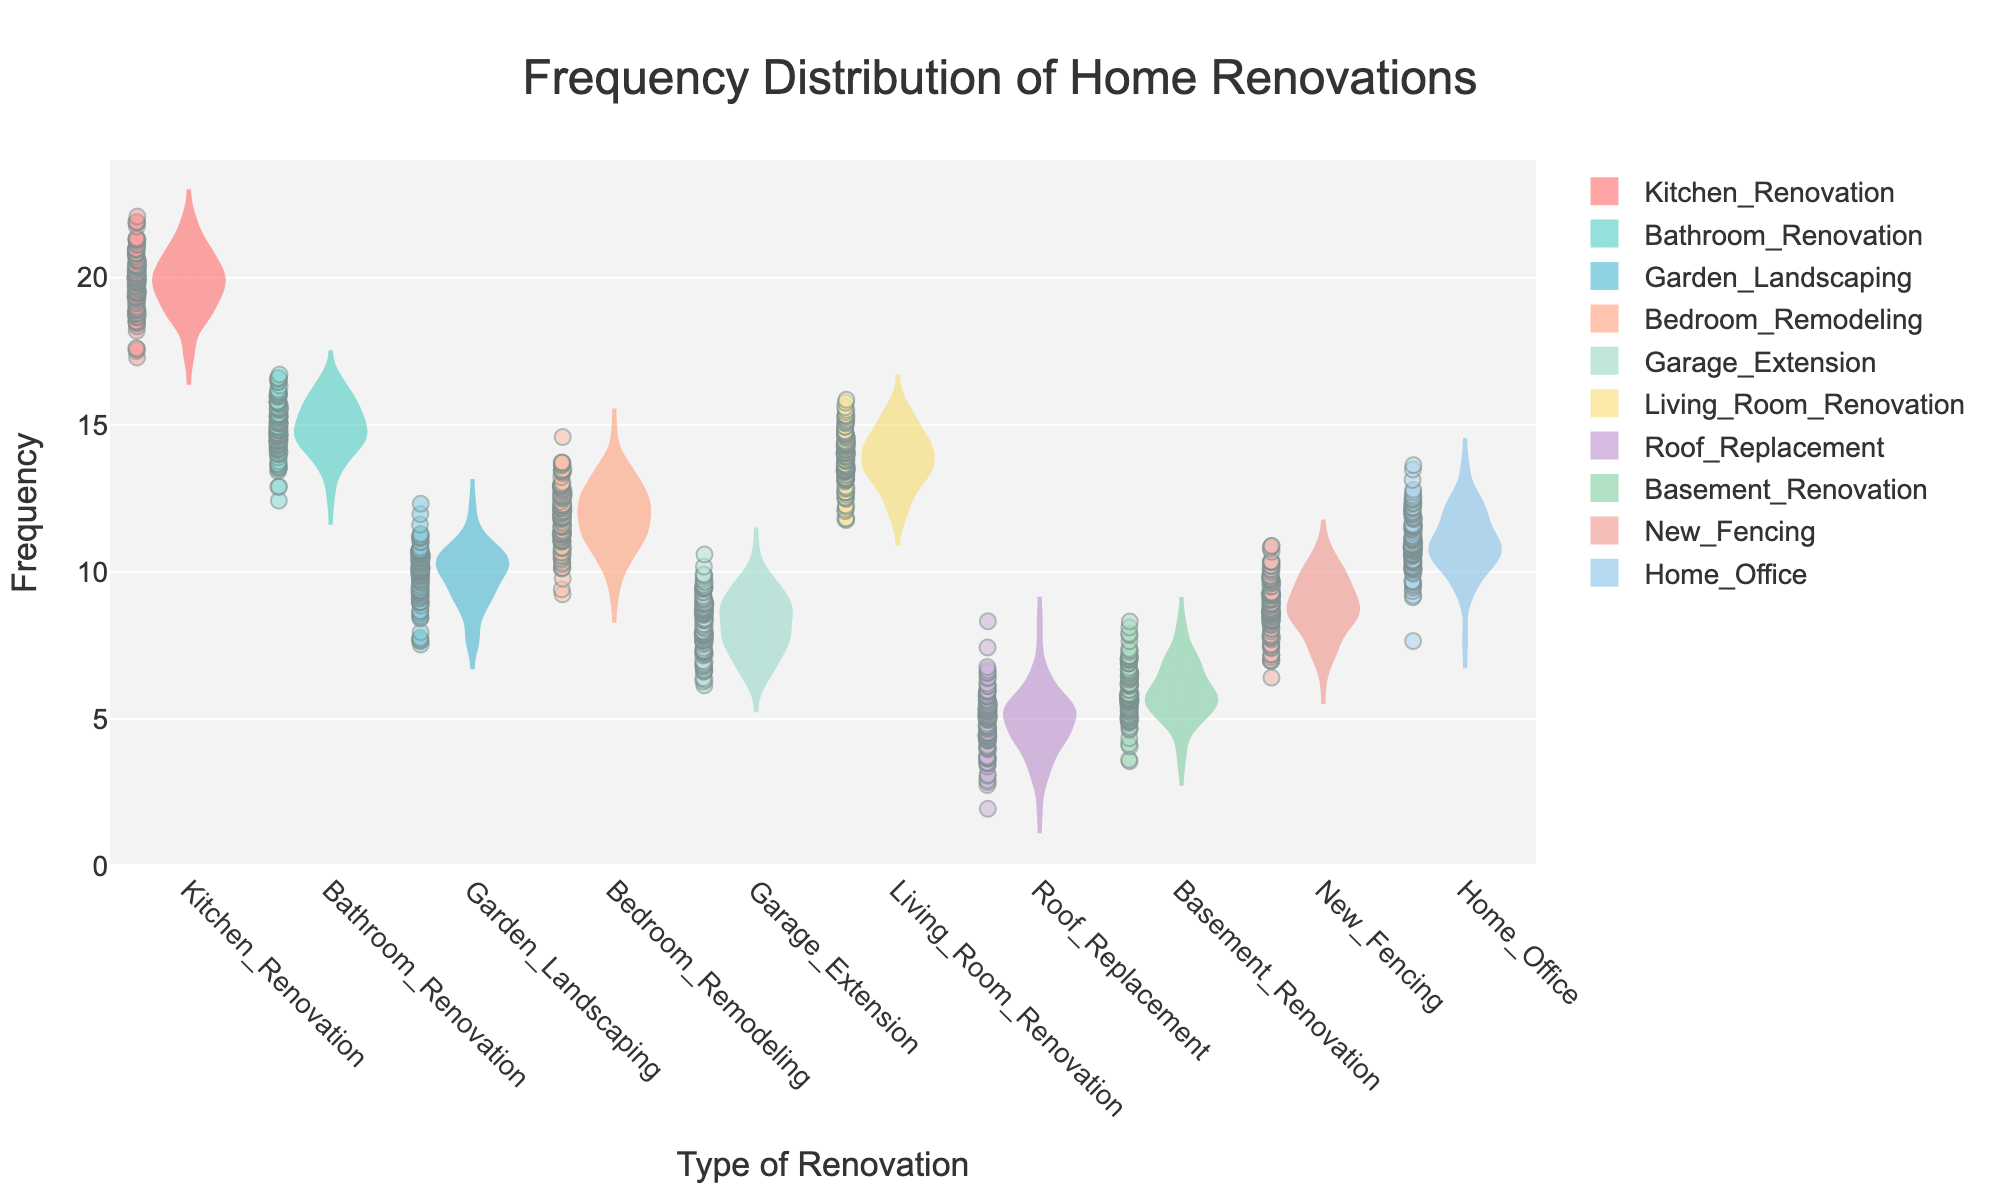What is the title of the figure? The title of the figure is usually found at the top and summarizes the main content of the chart. In this case, the title is shown at the top center of the plot.
Answer: Frequency Distribution of Home Renovations Which renovation type shows the highest frequency distribution? To determine the renovation type with the highest frequency distribution, look for the violin plot with the highest central mean line. The Kitchen Renovation has the highest mean.
Answer: Kitchen Renovation What is the range of the y-axis? The range of the y-axis can be identified by looking at the minimum and maximum values on the axis. Here, the y-axis range is from 0 to a value slightly beyond the maximum recorded frequency.
Answer: 0 to 24 How many renovation types are compared in the chart? Count the number of unique violin plots in the figure to determine the number of renovation types. Each plot represents a different type of renovation.
Answer: 10 Which renovation type has the lowest frequency distribution? Look for the violin plot with the lowest central mean line. Here, the Roof Replacement has the lowest mean frequency.
Answer: Roof Replacement What is the approximate mean frequency of Garden Landscaping renovations? The mean frequency of each violin plot can be identified by the horizontal line within the plot. For Garden Landscaping, it's around the central horizontal line.
Answer: 10 How does the frequency of Bathroom Renovation compare to Home Office renovations? Look at the central mean lines of each respective violin plot and compare. Bathroom Renovation has a mean slightly higher than Home Office.
Answer: Bathroom Renovation is higher What can you say about the variability within the Kitchen Renovation frequency? Examine the width and spread of the Kitchen Renovation's violin plot. A wider plot indicates higher variability, while a narrower plot denotes low variability. The Kitchen Renovation plot has moderate variability.
Answer: Moderate variability Which two renovation types have the closest mean frequencies? Compare the mean lines of different violin plots to identify the ones that are closest to each other. The Bathroom Renovation and Living Room Renovation plots are closest in mean frequency.
Answer: Bathroom and Living Room Renovations Is the data distribution in the Living Room Renovation violins plot symmetrical or skewed? Analyze the shape of the violin plot. If both halves are mirrored, it's symmetrical; otherwise, it's skewed. The Living Room Renovation plot shows slight skewness to one side.
Answer: Slightly skewed 